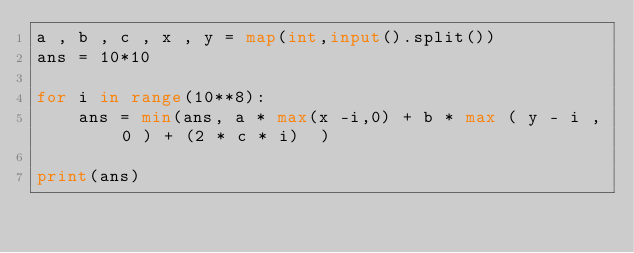<code> <loc_0><loc_0><loc_500><loc_500><_Python_>a , b , c , x , y = map(int,input().split())
ans = 10*10

for i in range(10**8):
    ans = min(ans, a * max(x -i,0) + b * max ( y - i , 0 ) + (2 * c * i)  )

print(ans)</code> 